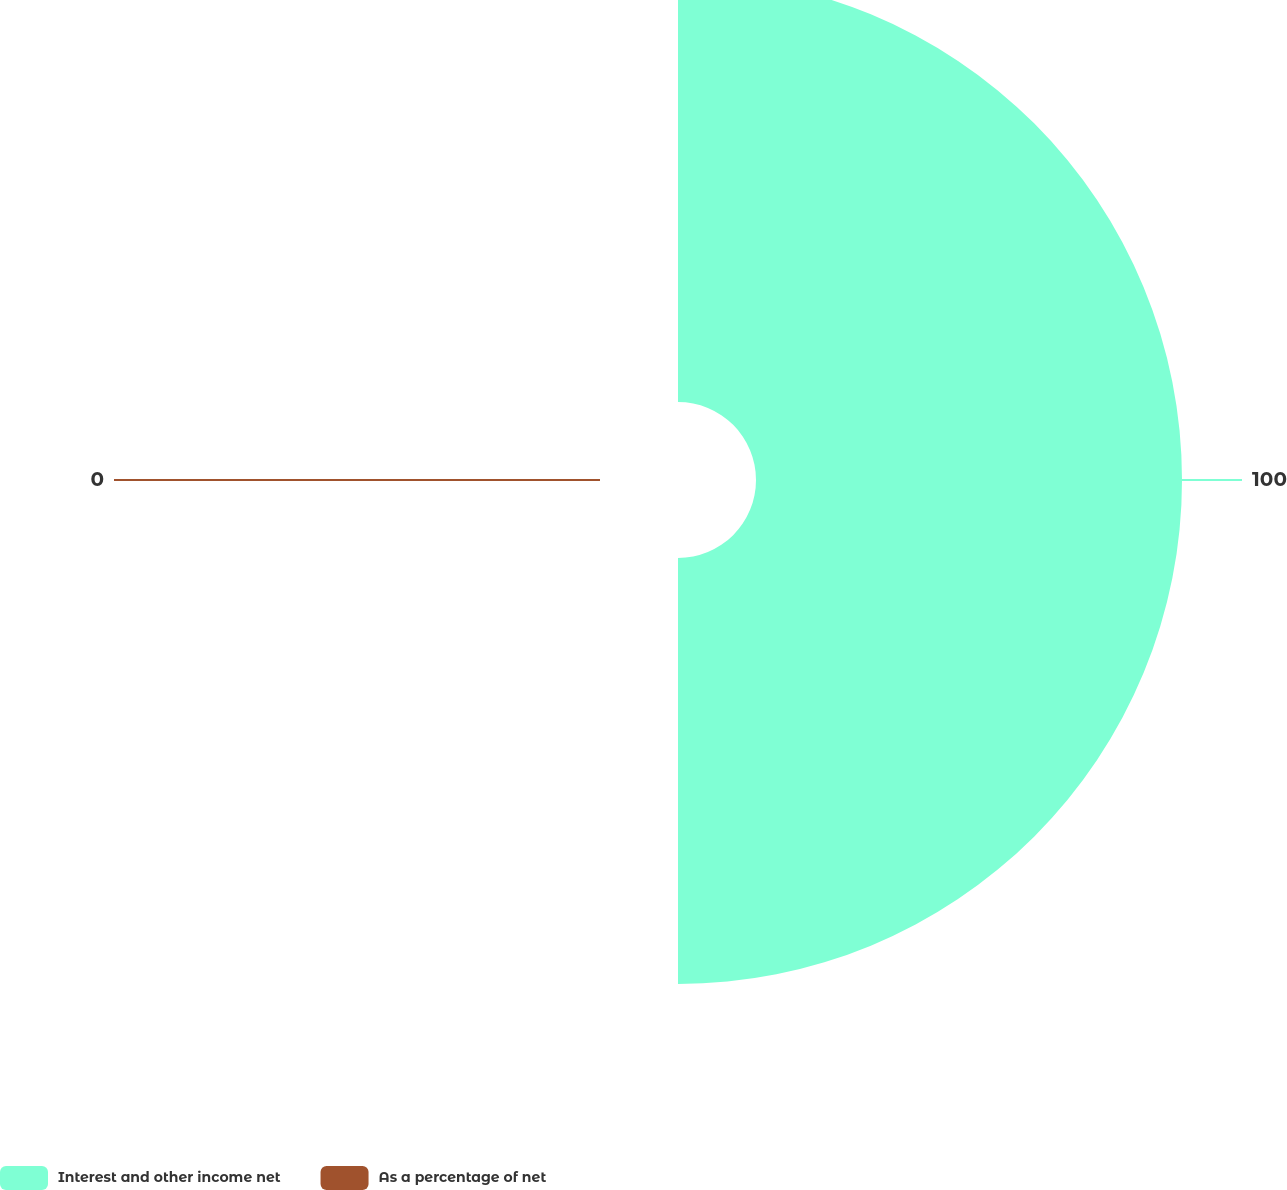<chart> <loc_0><loc_0><loc_500><loc_500><pie_chart><fcel>Interest and other income net<fcel>As a percentage of net<nl><fcel>100.0%<fcel>0.0%<nl></chart> 